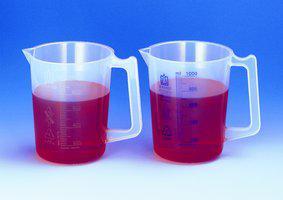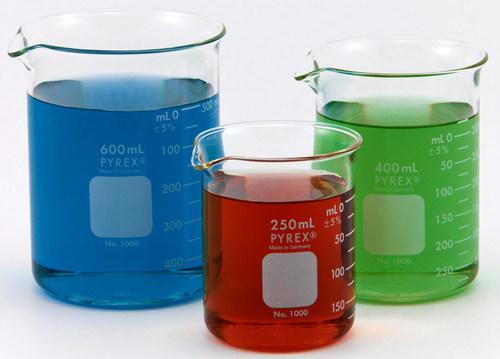The first image is the image on the left, the second image is the image on the right. For the images displayed, is the sentence "In at least one image there is one clear beaker bong with glass mouth peice." factually correct? Answer yes or no. No. The first image is the image on the left, the second image is the image on the right. Given the left and right images, does the statement "Each image contains colored liquid in a container, and at least one image includes a beaker without a handle containing red liquid." hold true? Answer yes or no. Yes. 